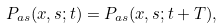Convert formula to latex. <formula><loc_0><loc_0><loc_500><loc_500>P _ { a s } ( x , s ; t ) = P _ { a s } ( x , s ; t + T ) ,</formula> 